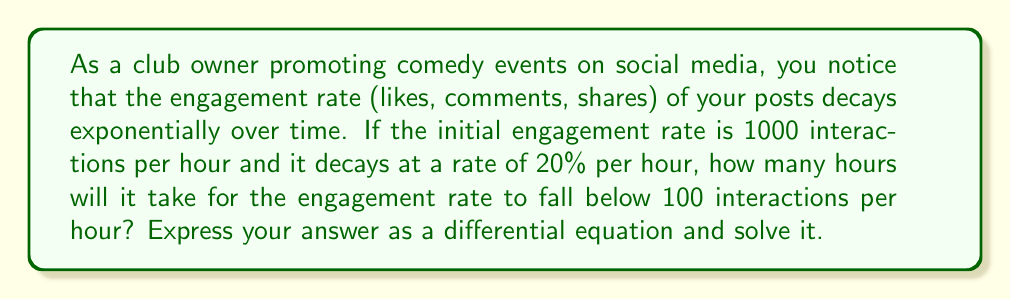Help me with this question. Let's approach this problem step-by-step:

1) Let $E(t)$ be the engagement rate at time $t$ (in hours).

2) The decay rate is 20% per hour, which means the rate of change is proportional to the current engagement rate. This can be expressed as a differential equation:

   $$\frac{dE}{dt} = -0.2E$$

3) We're given that the initial engagement rate is 1000 interactions per hour, so $E(0) = 1000$.

4) The general solution to this differential equation is:

   $$E(t) = Ce^{-0.2t}$$

   where $C$ is a constant we need to determine.

5) Using the initial condition, we can find $C$:

   $$1000 = Ce^{-0.2(0)}$$
   $$1000 = C$$

6) So our specific solution is:

   $$E(t) = 1000e^{-0.2t}$$

7) We want to find when $E(t) < 100$. Let's set up this inequality:

   $$1000e^{-0.2t} < 100$$

8) Dividing both sides by 1000:

   $$e^{-0.2t} < 0.1$$

9) Taking the natural log of both sides:

   $$-0.2t < \ln(0.1)$$

10) Dividing both sides by -0.2:

    $$t > -\frac{\ln(0.1)}{0.2} \approx 11.51$$

Therefore, it will take about 11.51 hours for the engagement rate to fall below 100 interactions per hour.
Answer: The engagement rate $E(t)$ is governed by the differential equation $\frac{dE}{dt} = -0.2E$ with initial condition $E(0) = 1000$. The solution is $E(t) = 1000e^{-0.2t}$, and it will take approximately 11.51 hours for the engagement rate to fall below 100 interactions per hour. 